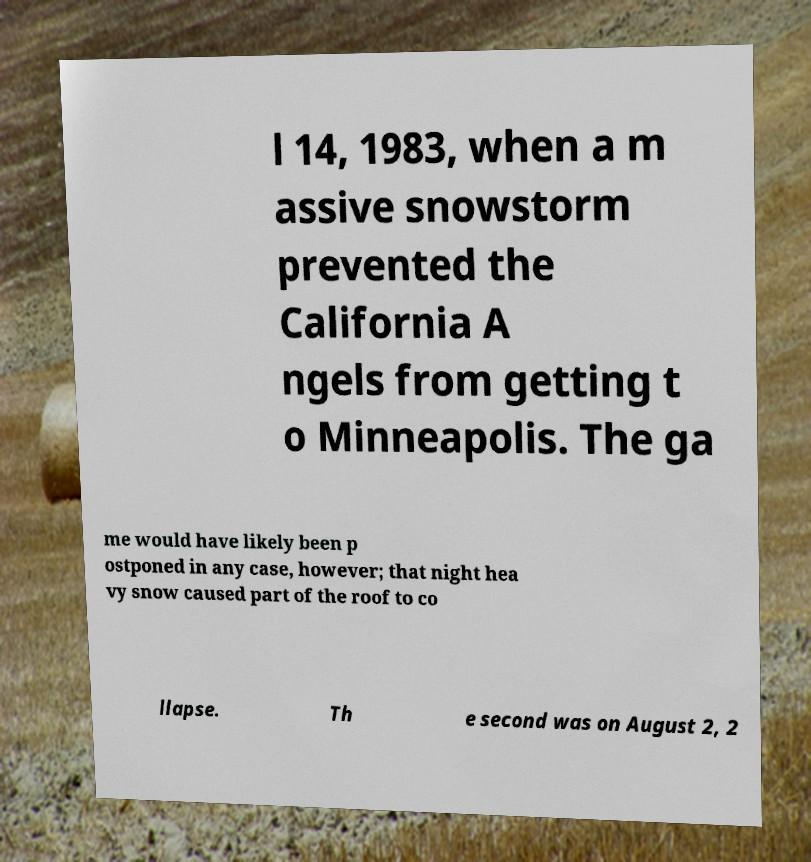There's text embedded in this image that I need extracted. Can you transcribe it verbatim? l 14, 1983, when a m assive snowstorm prevented the California A ngels from getting t o Minneapolis. The ga me would have likely been p ostponed in any case, however; that night hea vy snow caused part of the roof to co llapse. Th e second was on August 2, 2 